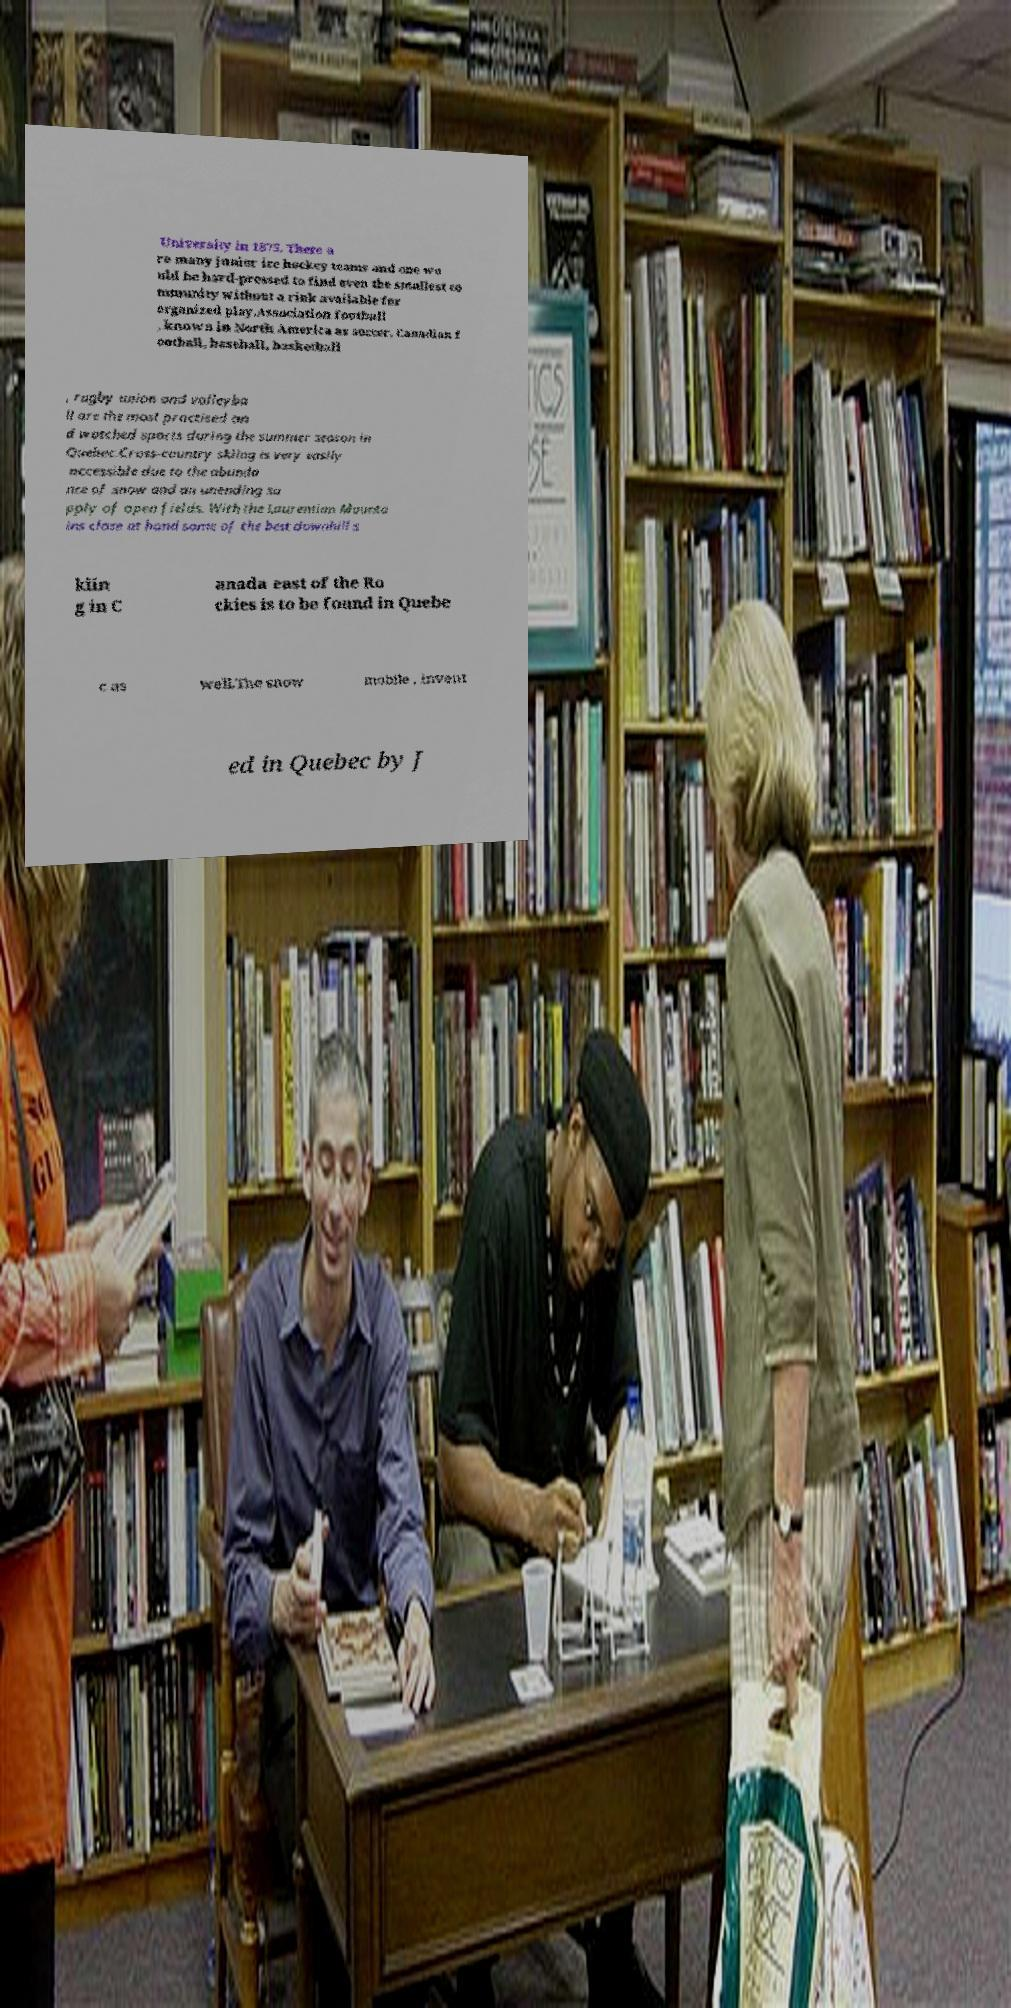Can you read and provide the text displayed in the image?This photo seems to have some interesting text. Can you extract and type it out for me? University in 1875. There a re many junior ice hockey teams and one wo uld be hard-pressed to find even the smallest co mmunity without a rink available for organized play.Association football , known in North America as soccer, Canadian f ootball, baseball, basketball , rugby union and volleyba ll are the most practised an d watched sports during the summer season in Quebec.Cross-country skiing is very easily accessible due to the abunda nce of snow and an unending su pply of open fields. With the Laurentian Mounta ins close at hand some of the best downhill s kiin g in C anada east of the Ro ckies is to be found in Quebe c as well.The snow mobile , invent ed in Quebec by J 